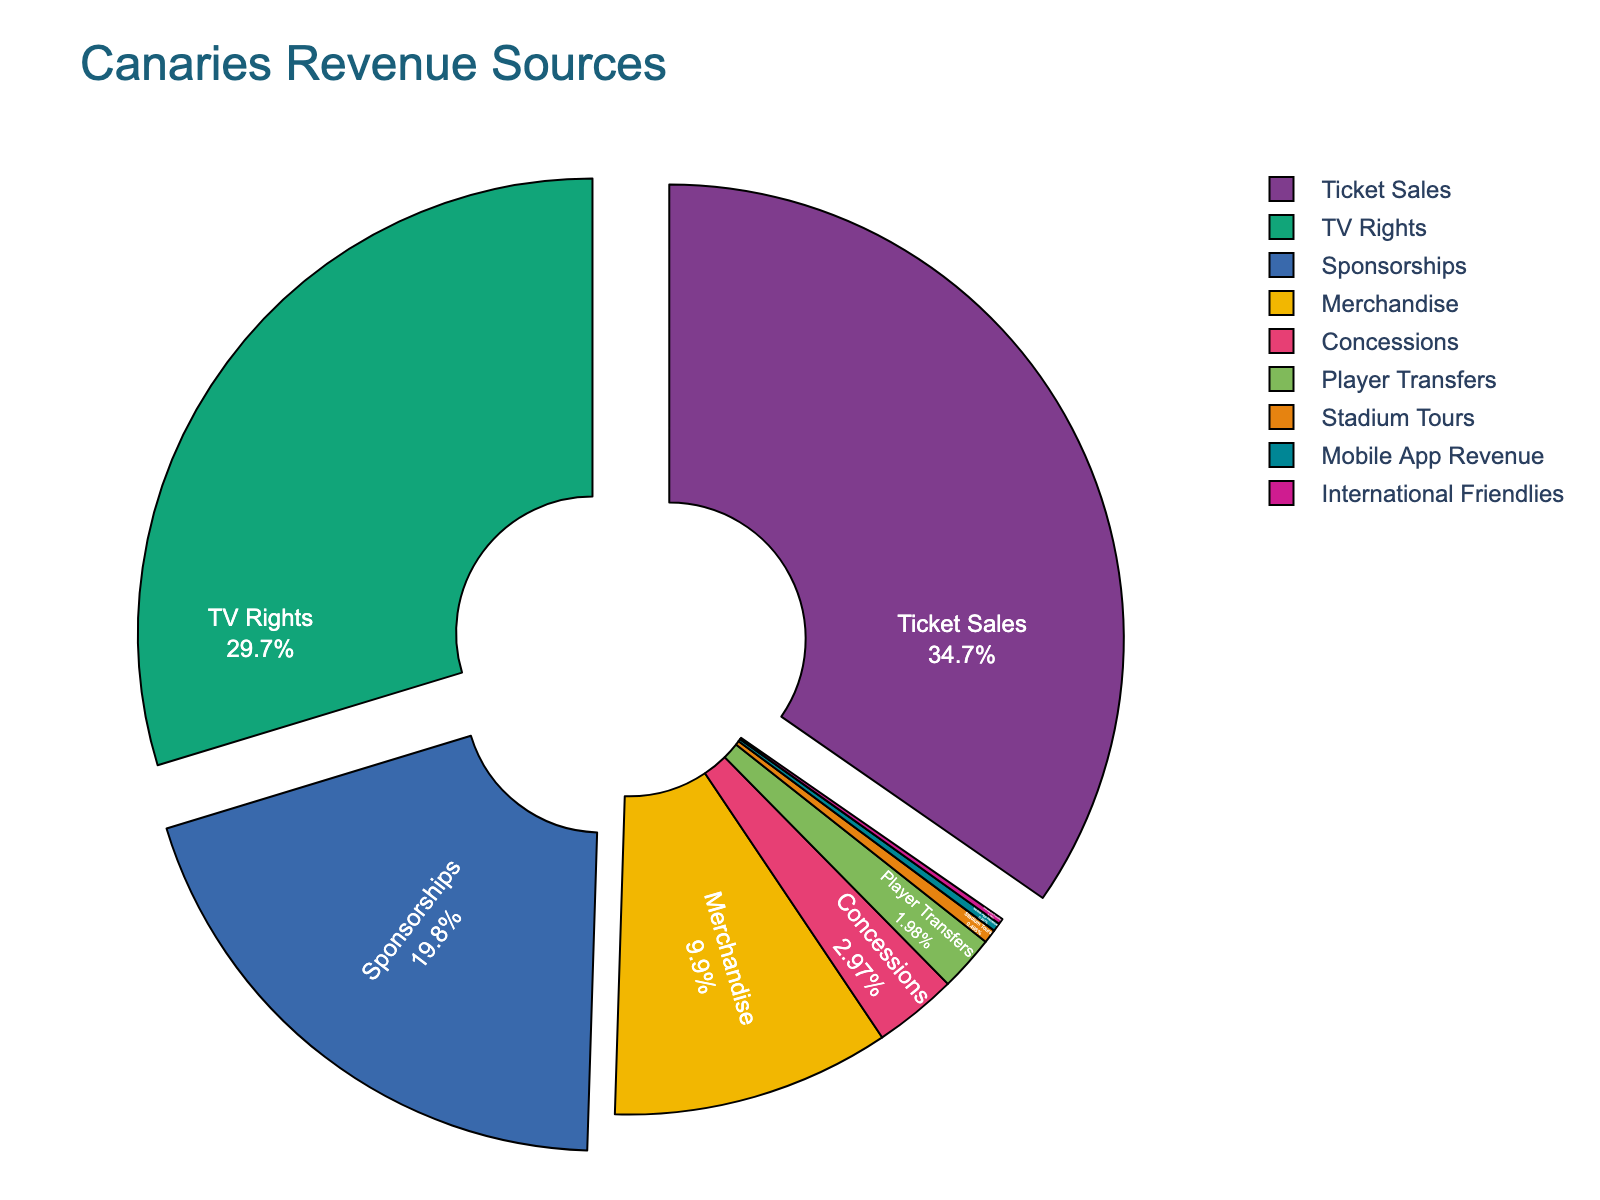What's the largest revenue source for the Canaries? The figure shows a pie chart with different revenue sources. By observing the segments, we see that 'Ticket Sales' has the largest portion of the pie.
Answer: Ticket Sales Which revenue source has nearly double the percentage of Merchandise? Merchandise accounts for 10% of the total revenue. TV Rights, which contributes 30%, is significantly higher. Double of 10% is 20%, but TV Rights at 30% is nearly triple, not just double. Instead, Sponsorships at 20% are double the percentage of Merchandise.
Answer: Sponsorships How do Merchandise and Concessions' shares compare visually? Merchandise has a 10% share, appearing much larger than Concessions, which stands at 3%. The segment for Merchandise is substantially bigger than that for Concessions on the pie chart.
Answer: Merchandise is much larger What is the combined percentage share of the three smallest revenue sources? The three smallest revenue sources are Stadium Tours (0.5%), Mobile App Revenue (0.3%), and International Friendlies (0.2%). Adding these gives us 0.5% + 0.3% + 0.2% = 1%.
Answer: 1% Which source pulls its segment from the center of the chart, and what is its percentage? The segments that are pulled (detached) slightly from the center are Ticket Sales, TV Rights, and Sponsorships. Among these, Ticket Sales is the largest, contributing 35%.
Answer: Ticket Sales, 35% How much more does TV Rights contribute to revenue than Player Transfers? TV Rights contribute 30%, while Player Transfers contribute 2%. The difference is 30% - 2% = 28%.
Answer: 28% Which revenue sources collectively make up less than 5% of the total revenue? Summing up the smallest percentages: Concessions (3%), Player Transfers (2%), Stadium Tours (0.5%), Mobile App Revenue (0.3%), and International Friendlies (0.2%). The combined share is 3% + 2% + 0.5% + 0.3% + 0.2% = 6%. Thus, only Mobile App Revenue (0.3%), Stadium Tours (0.5%), and International Friendlies (0.2%) collectively make up less than 5%.
Answer: Mobile App Revenue, Stadium Tours, International Friendlies What's the visual clue that identifies the major revenue sources in the pie chart? The larger segments are pulled slightly from the center, representing Ticket Sales, TV Rights, and Sponsorships. This highlights their importance as major revenue sources.
Answer: Pulled segments How much of the total revenue is made up by Ticket Sales and Sponsorships combined? Ticket Sales account for 35%, and Sponsorships account for 20%. Combined, their share is 35% + 20% = 55%.
Answer: 55% What is the least contributing revenue source, and what percentage does it represent? The pie chart indicates the smallest segment is for International Friendlies, which contributes 0.2%.
Answer: International Friendlies, 0.2% 